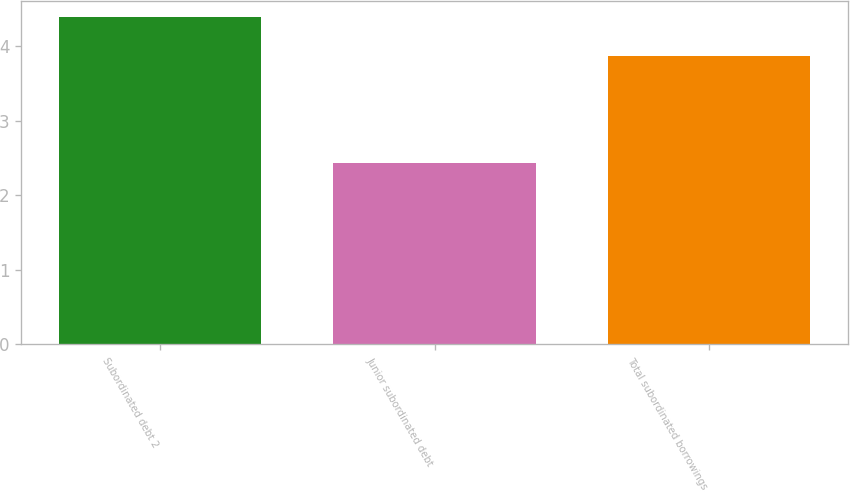Convert chart. <chart><loc_0><loc_0><loc_500><loc_500><bar_chart><fcel>Subordinated debt 2<fcel>Junior subordinated debt<fcel>Total subordinated borrowings<nl><fcel>4.39<fcel>2.43<fcel>3.87<nl></chart> 